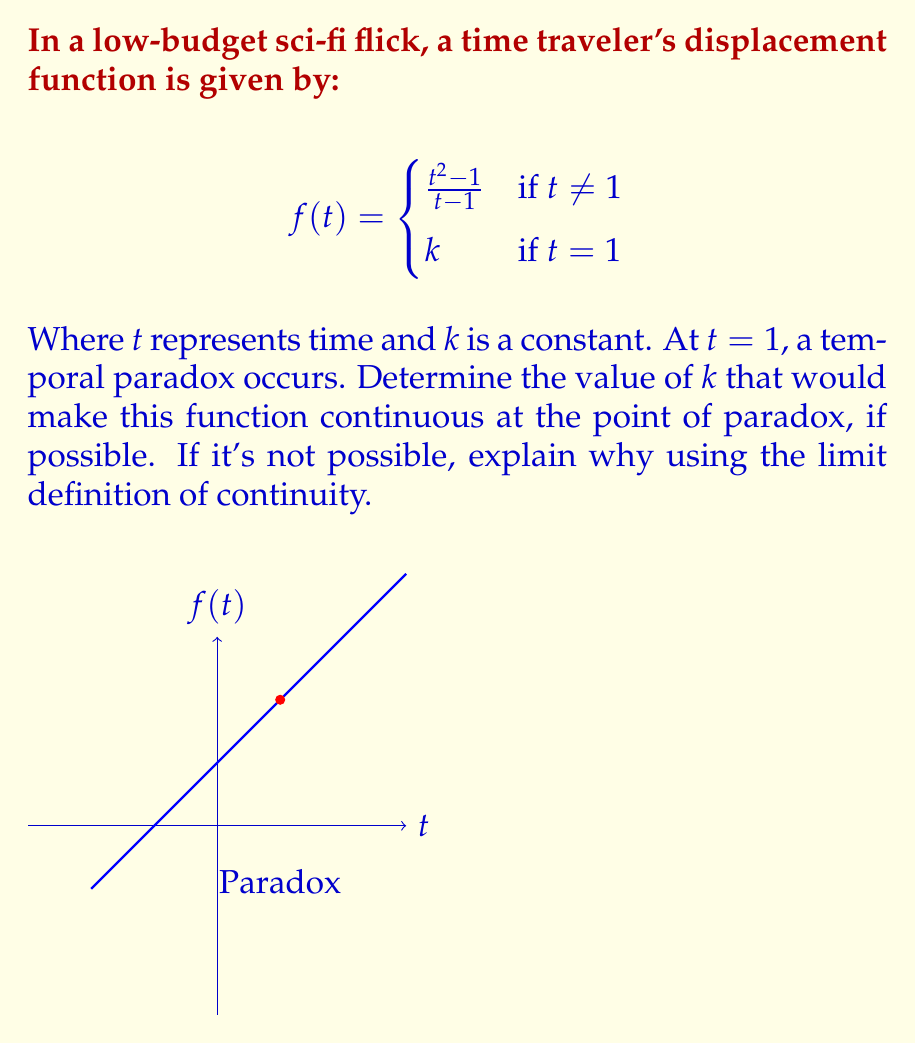Can you solve this math problem? Let's approach this step-by-step:

1) For a function to be continuous at a point, the limit of the function as we approach the point from both sides must exist and be equal to the function's value at that point.

2) We need to find $\lim_{t \to 1} f(t)$:

   $$\lim_{t \to 1} f(t) = \lim_{t \to 1} \frac{t^2 - 1}{t - 1}$$

3) This is an indeterminate form (0/0), so we can use L'Hôpital's rule or factor the numerator:

   $$\lim_{t \to 1} \frac{t^2 - 1}{t - 1} = \lim_{t \to 1} \frac{(t+1)(t-1)}{t-1} = \lim_{t \to 1} (t+1) = 2$$

4) For the function to be continuous at $t = 1$, we need:

   $$\lim_{t \to 1^-} f(t) = \lim_{t \to 1^+} f(t) = f(1) = k = 2$$

5) Therefore, the function will be continuous at the point of paradox ($t = 1$) if and only if $k = 2$.

6) We can verify this by checking the three conditions for continuity:
   - $f(1)$ is defined (it equals $k$)
   - $\lim_{t \to 1} f(t)$ exists (we found it to be 2)
   - $\lim_{t \to 1} f(t) = f(1)$ (true when $k = 2$)
Answer: $k = 2$ 